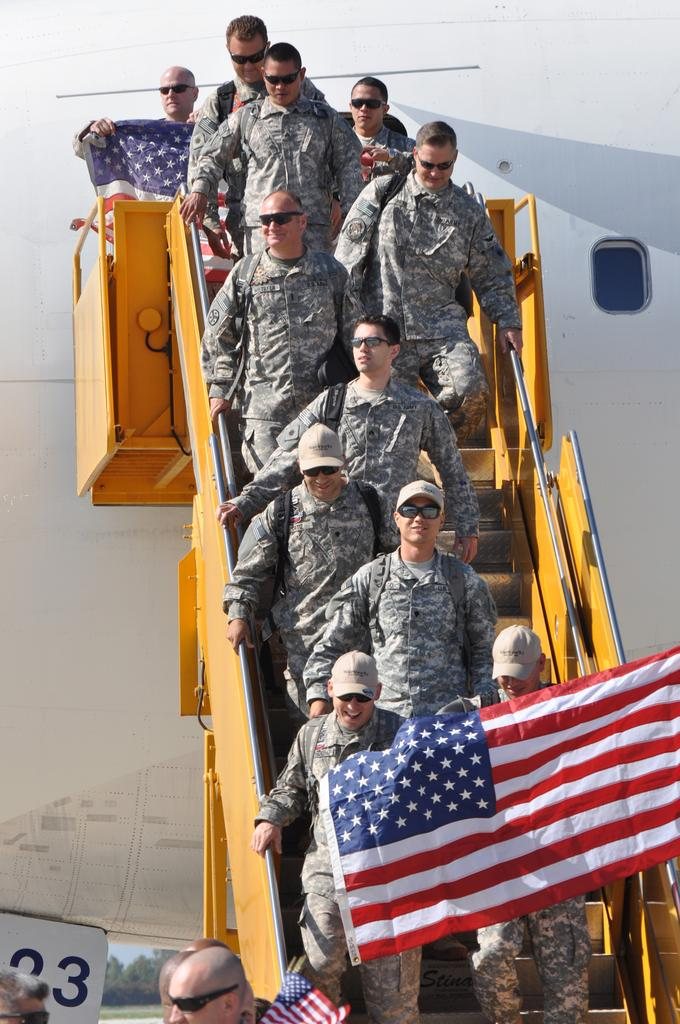What is the main subject of the image? The main subject of the image is a flight with steps. How many people are in the image? There are many people in the image. What accessories are some people wearing? Some people are wearing caps and goggles. What can be seen in the image besides the people and flight with steps? There are flags and a number at the bottom of the image. What type of insurance is being sold at the bottom of the image? There is no mention of insurance in the image; it only contains a number at the bottom. How does the heat affect the people in the image? The image does not provide any information about the temperature or heat, so it cannot be determined how it affects the people. 